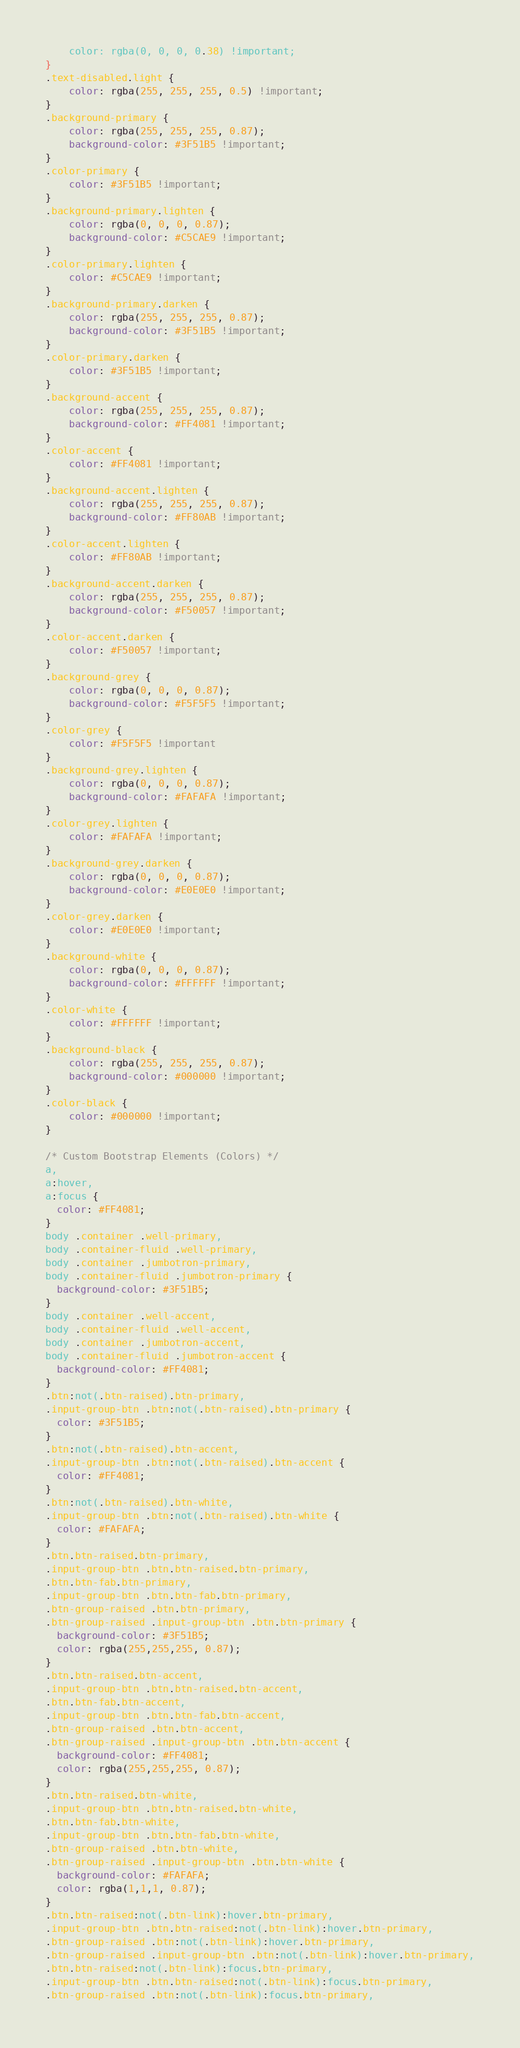<code> <loc_0><loc_0><loc_500><loc_500><_CSS_>    color: rgba(0, 0, 0, 0.38) !important;
}
.text-disabled.light {
    color: rgba(255, 255, 255, 0.5) !important;
}
.background-primary {
    color: rgba(255, 255, 255, 0.87);
    background-color: #3F51B5 !important;
}
.color-primary {
    color: #3F51B5 !important;
}
.background-primary.lighten {
    color: rgba(0, 0, 0, 0.87);
    background-color: #C5CAE9 !important;
}
.color-primary.lighten {
    color: #C5CAE9 !important;
}
.background-primary.darken {
    color: rgba(255, 255, 255, 0.87);
    background-color: #3F51B5 !important;
}
.color-primary.darken {
    color: #3F51B5 !important;
}
.background-accent {
    color: rgba(255, 255, 255, 0.87);
    background-color: #FF4081 !important;
}
.color-accent {
    color: #FF4081 !important;
}
.background-accent.lighten {
    color: rgba(255, 255, 255, 0.87);
    background-color: #FF80AB !important;
}
.color-accent.lighten {
    color: #FF80AB !important;
}
.background-accent.darken {
    color: rgba(255, 255, 255, 0.87);
    background-color: #F50057 !important;
}
.color-accent.darken {
    color: #F50057 !important;
}
.background-grey {
    color: rgba(0, 0, 0, 0.87);
    background-color: #F5F5F5 !important;
}
.color-grey {
    color: #F5F5F5 !important
}
.background-grey.lighten {
    color: rgba(0, 0, 0, 0.87);
    background-color: #FAFAFA !important;
}
.color-grey.lighten {
    color: #FAFAFA !important;
}
.background-grey.darken {
    color: rgba(0, 0, 0, 0.87);
    background-color: #E0E0E0 !important;
}
.color-grey.darken {
    color: #E0E0E0 !important;
}
.background-white {
    color: rgba(0, 0, 0, 0.87);
    background-color: #FFFFFF !important;
}
.color-white {
    color: #FFFFFF !important;
}
.background-black {
    color: rgba(255, 255, 255, 0.87);
    background-color: #000000 !important;
}
.color-black {
    color: #000000 !important;
}

/* Custom Bootstrap Elements (Colors) */
a,
a:hover,
a:focus {
  color: #FF4081;
}
body .container .well-primary,
body .container-fluid .well-primary,
body .container .jumbotron-primary,
body .container-fluid .jumbotron-primary {
  background-color: #3F51B5;
}
body .container .well-accent,
body .container-fluid .well-accent,
body .container .jumbotron-accent,
body .container-fluid .jumbotron-accent {
  background-color: #FF4081;
}
.btn:not(.btn-raised).btn-primary,
.input-group-btn .btn:not(.btn-raised).btn-primary {
  color: #3F51B5;
}
.btn:not(.btn-raised).btn-accent,
.input-group-btn .btn:not(.btn-raised).btn-accent {
  color: #FF4081;
}
.btn:not(.btn-raised).btn-white,
.input-group-btn .btn:not(.btn-raised).btn-white {
  color: #FAFAFA;
}
.btn.btn-raised.btn-primary,
.input-group-btn .btn.btn-raised.btn-primary,
.btn.btn-fab.btn-primary,
.input-group-btn .btn.btn-fab.btn-primary,
.btn-group-raised .btn.btn-primary,
.btn-group-raised .input-group-btn .btn.btn-primary {
  background-color: #3F51B5;
  color: rgba(255,255,255, 0.87);
}
.btn.btn-raised.btn-accent,
.input-group-btn .btn.btn-raised.btn-accent,
.btn.btn-fab.btn-accent,
.input-group-btn .btn.btn-fab.btn-accent,
.btn-group-raised .btn.btn-accent,
.btn-group-raised .input-group-btn .btn.btn-accent {
  background-color: #FF4081;
  color: rgba(255,255,255, 0.87);
}
.btn.btn-raised.btn-white,
.input-group-btn .btn.btn-raised.btn-white,
.btn.btn-fab.btn-white,
.input-group-btn .btn.btn-fab.btn-white,
.btn-group-raised .btn.btn-white,
.btn-group-raised .input-group-btn .btn.btn-white {
  background-color: #FAFAFA;
  color: rgba(1,1,1, 0.87);
}
.btn.btn-raised:not(.btn-link):hover.btn-primary,
.input-group-btn .btn.btn-raised:not(.btn-link):hover.btn-primary,
.btn-group-raised .btn:not(.btn-link):hover.btn-primary,
.btn-group-raised .input-group-btn .btn:not(.btn-link):hover.btn-primary,
.btn.btn-raised:not(.btn-link):focus.btn-primary,
.input-group-btn .btn.btn-raised:not(.btn-link):focus.btn-primary,
.btn-group-raised .btn:not(.btn-link):focus.btn-primary,</code> 